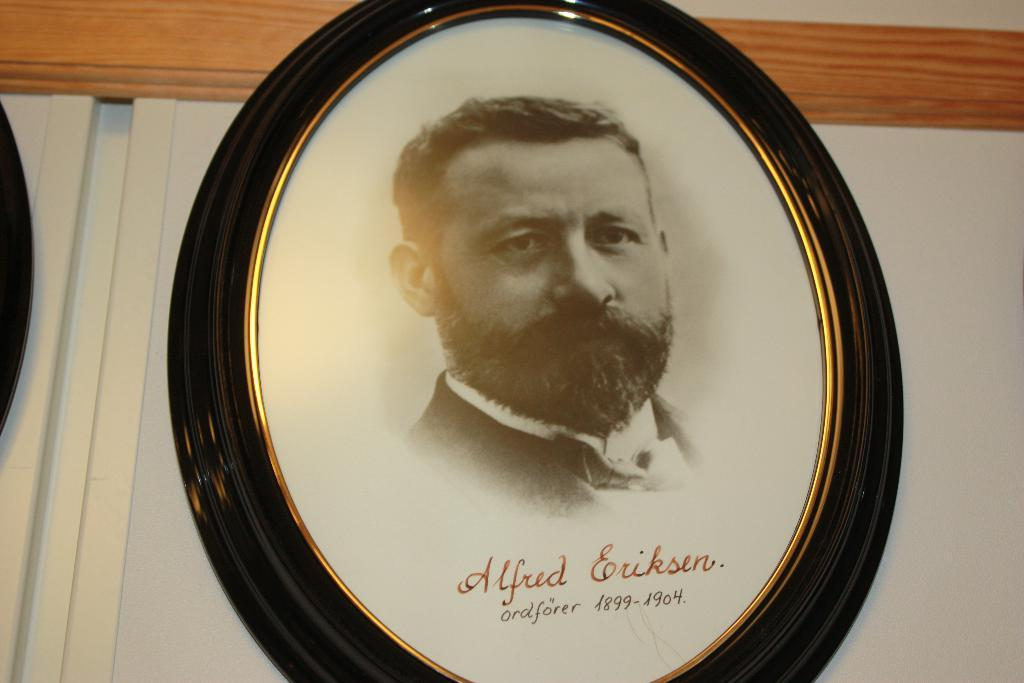What object is present in the image that holds a picture? There is a photo frame in the image that holds a picture. Who is in the picture inside the photo frame? The photo frame contains a picture of a man. Where is the photo frame located in the image? The photo frame is placed on a white wall. What additional information is provided at the bottom of the picture? There is text written at the bottom of the photo. What type of pail is being used to water the rose in the image? There is no pail or rose present in the image; it only features a photo frame with a picture of a man on a white wall. 